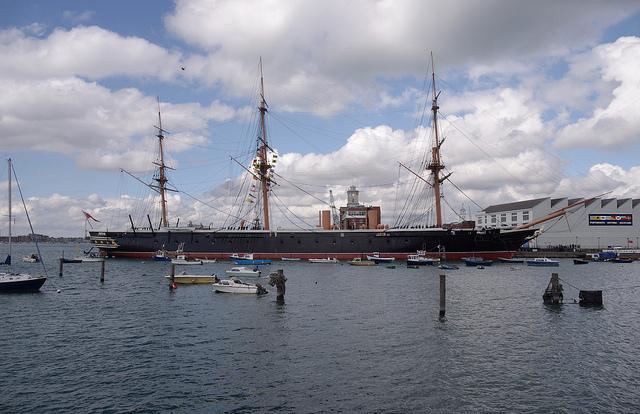What color is the boat in front?
Concise answer only. White. Are there clouds visible?
Be succinct. Yes. How many boats are under these gray clouds?
Be succinct. 6. Is it spring?
Write a very short answer. Yes. Are there clouds in the sky?
Be succinct. Yes. Is this a sailing boat?
Answer briefly. No. What time of day is it?
Write a very short answer. Noon. What color is the closest boat?
Quick response, please. White. Is the bridge visible in the picture?
Be succinct. No. Is this a major port?
Concise answer only. Yes. What flag is flying in image?
Give a very brief answer. No flag. What is the boat doing?
Short answer required. Floating. Where is the bow of the boat?
Concise answer only. On right. Is that a fishing pole off the deck in the back?
Concise answer only. No. Are all of the boats parked?
Quick response, please. No. 